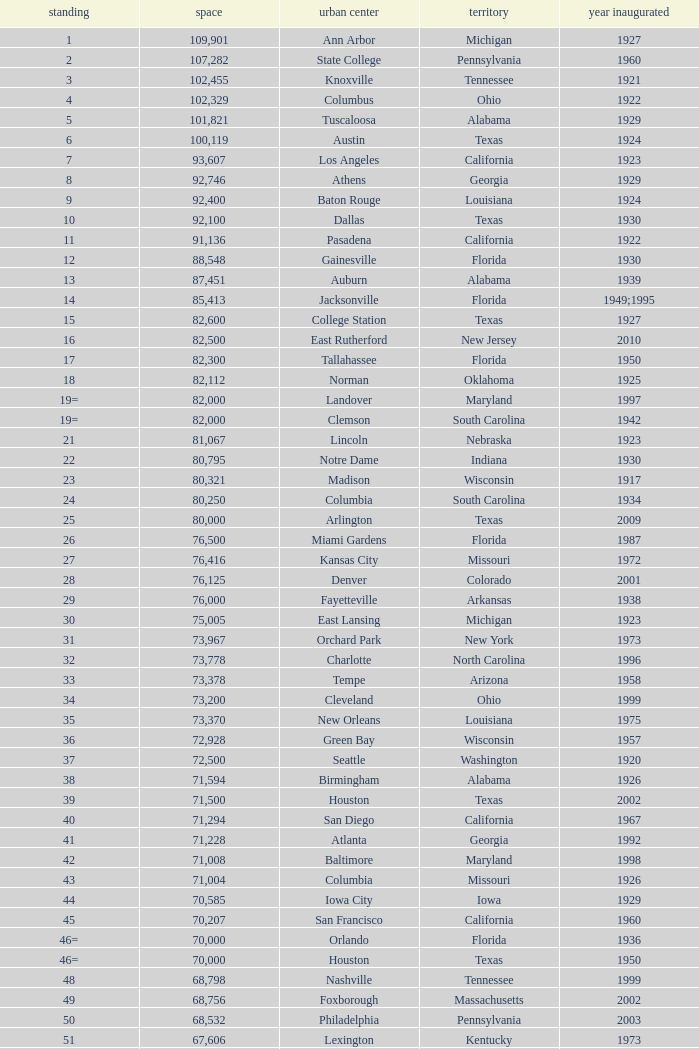What is the rank for the year opened in 1959 in Pennsylvania? 134=. 